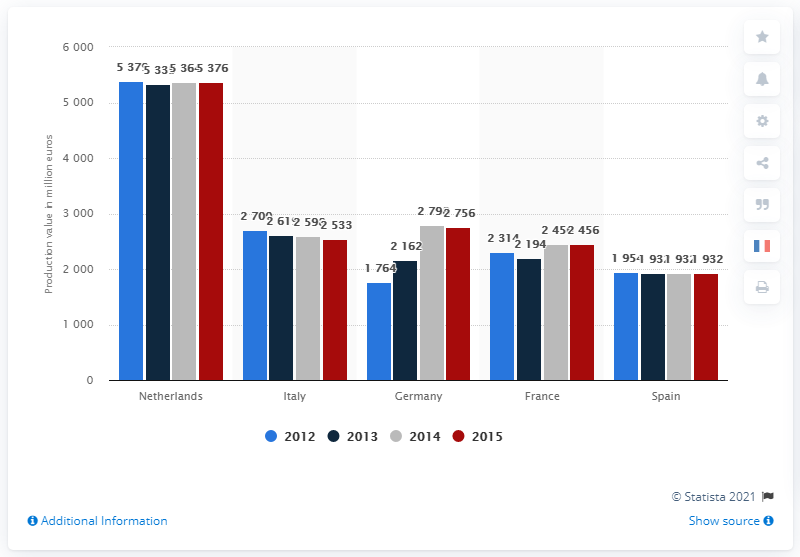Draw attention to some important aspects in this diagram. According to data from 2015, the production value of flowers and plants in the Netherlands was 5,335.. 